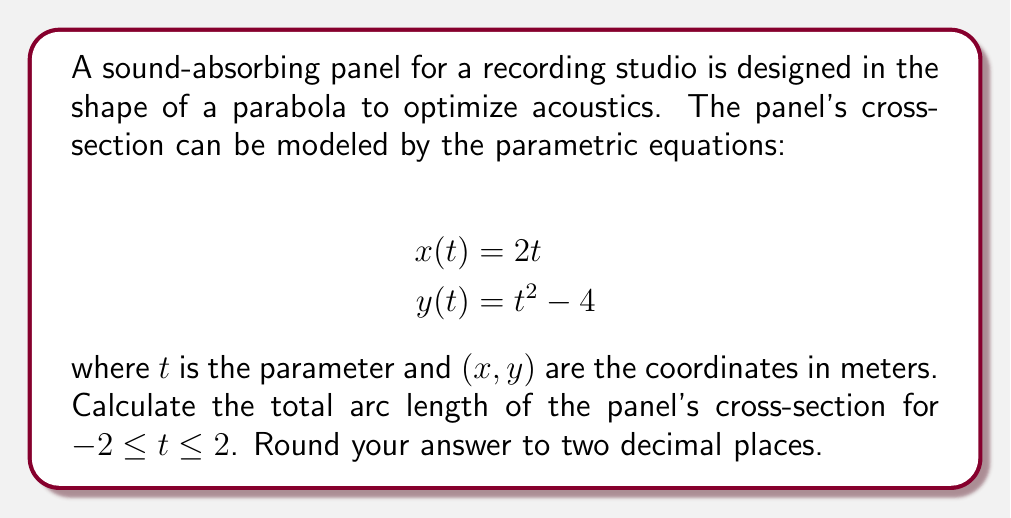Can you solve this math problem? To find the arc length of a curve defined by parametric equations, we use the formula:

$$L = \int_{a}^{b} \sqrt{\left(\frac{dx}{dt}\right)^2 + \left(\frac{dy}{dt}\right)^2} dt$$

where $a$ and $b$ are the lower and upper bounds of the parameter $t$.

Step 1: Find $\frac{dx}{dt}$ and $\frac{dy}{dt}$
$$\frac{dx}{dt} = 2$$
$$\frac{dy}{dt} = 2t$$

Step 2: Substitute these into the arc length formula
$$L = \int_{-2}^{2} \sqrt{(2)^2 + (2t)^2} dt$$
$$L = \int_{-2}^{2} \sqrt{4 + 4t^2} dt$$
$$L = 2\int_{-2}^{2} \sqrt{1 + t^2} dt$$

Step 3: This integral is of the form $\int \sqrt{1 + t^2} dt$, which has the antiderivative:
$$\frac{1}{2}(t\sqrt{1+t^2} + \ln|t + \sqrt{1+t^2}|) + C$$

Step 4: Apply the limits
$$L = \left[\frac{1}{2}(t\sqrt{1+t^2} + \ln|t + \sqrt{1+t^2}|)\right]_{-2}^{2}$$

Step 5: Evaluate
$$L = \frac{1}{2}(2\sqrt{1+2^2} + \ln|2 + \sqrt{1+2^2}|) - \frac{1}{2}(-2\sqrt{1+(-2)^2} + \ln|-2 + \sqrt{1+(-2)^2}|)$$
$$L = \frac{1}{2}(2\sqrt{5} + \ln(2 + \sqrt{5})) - \frac{1}{2}(-2\sqrt{5} + \ln(2 + \sqrt{5}))$$
$$L = 2\sqrt{5} + \ln(2 + \sqrt{5})$$

Step 6: Calculate and round to two decimal places
$$L \approx 8.69 \text{ meters}$$
Answer: 8.69 meters 